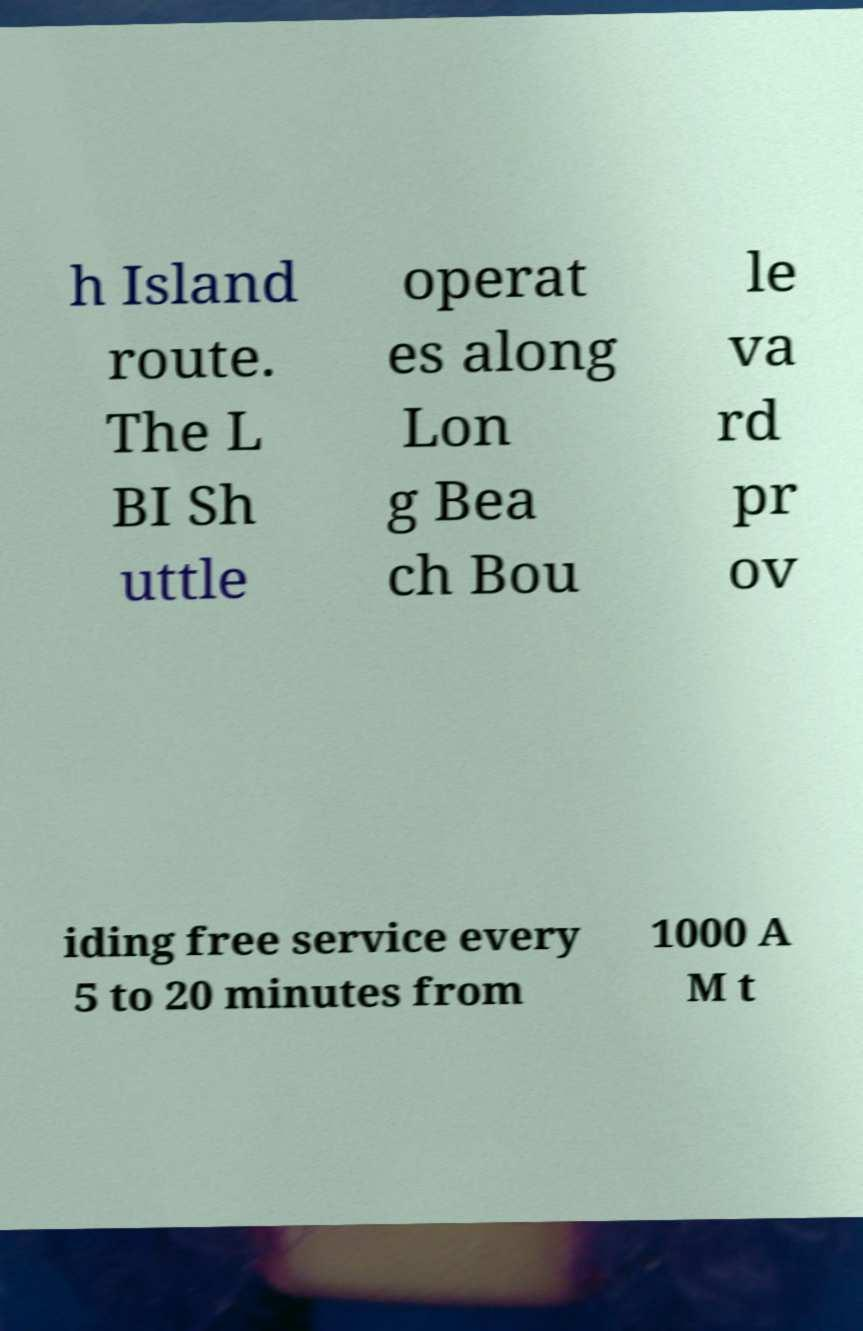Can you accurately transcribe the text from the provided image for me? h Island route. The L BI Sh uttle operat es along Lon g Bea ch Bou le va rd pr ov iding free service every 5 to 20 minutes from 1000 A M t 